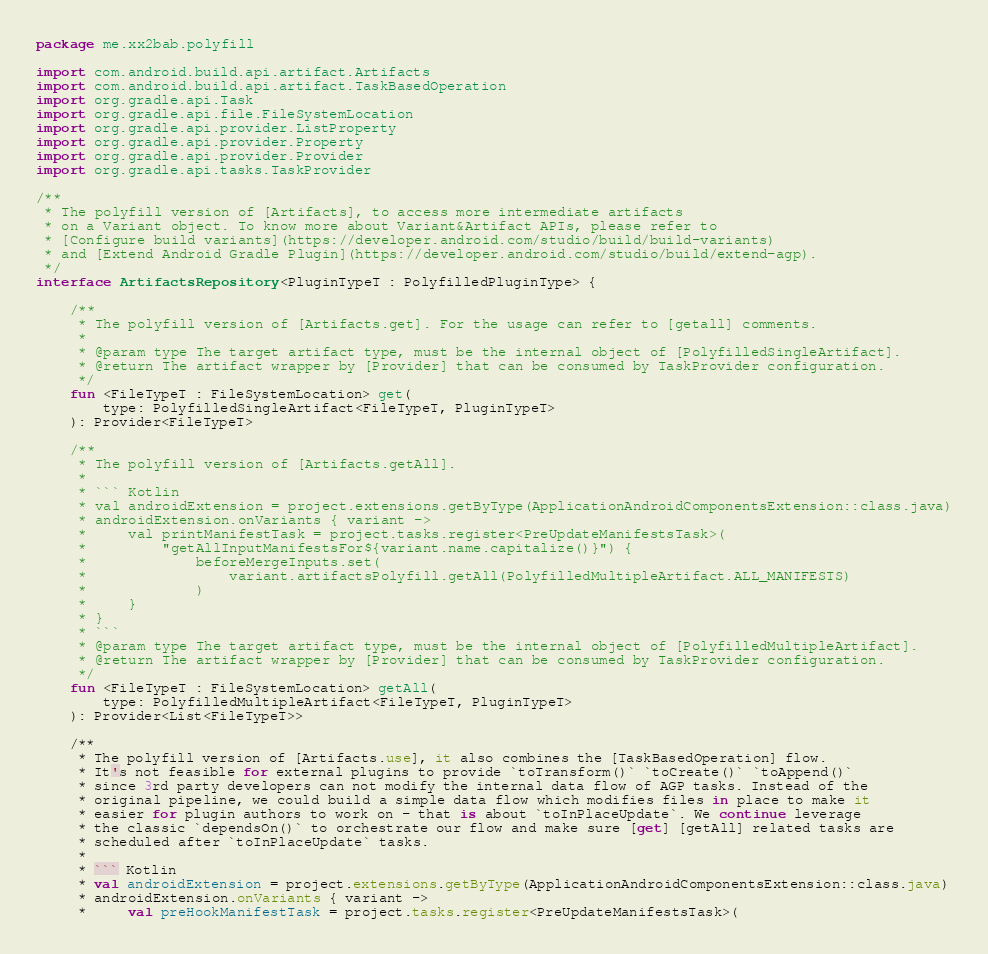Convert code to text. <code><loc_0><loc_0><loc_500><loc_500><_Kotlin_>package me.xx2bab.polyfill

import com.android.build.api.artifact.Artifacts
import com.android.build.api.artifact.TaskBasedOperation
import org.gradle.api.Task
import org.gradle.api.file.FileSystemLocation
import org.gradle.api.provider.ListProperty
import org.gradle.api.provider.Property
import org.gradle.api.provider.Provider
import org.gradle.api.tasks.TaskProvider

/**
 * The polyfill version of [Artifacts], to access more intermediate artifacts
 * on a Variant object. To know more about Variant&Artifact APIs, please refer to
 * [Configure build variants](https://developer.android.com/studio/build/build-variants)
 * and [Extend Android Gradle Plugin](https://developer.android.com/studio/build/extend-agp).
 */
interface ArtifactsRepository<PluginTypeT : PolyfilledPluginType> {

    /**
     * The polyfill version of [Artifacts.get]. For the usage can refer to [getall] comments.
     *
     * @param type The target artifact type, must be the internal object of [PolyfilledSingleArtifact].
     * @return The artifact wrapper by [Provider] that can be consumed by TaskProvider configuration.
     */
    fun <FileTypeT : FileSystemLocation> get(
        type: PolyfilledSingleArtifact<FileTypeT, PluginTypeT>
    ): Provider<FileTypeT>

    /**
     * The polyfill version of [Artifacts.getAll].
     *
     * ``` Kotlin
     * val androidExtension = project.extensions.getByType(ApplicationAndroidComponentsExtension::class.java)
     * androidExtension.onVariants { variant ->
     *     val printManifestTask = project.tasks.register<PreUpdateManifestsTask>(
     *         "getAllInputManifestsFor${variant.name.capitalize()}") {
     *             beforeMergeInputs.set(
     *                 variant.artifactsPolyfill.getAll(PolyfilledMultipleArtifact.ALL_MANIFESTS)
     *             )
     *     }
     * }
     * ```
     * @param type The target artifact type, must be the internal object of [PolyfilledMultipleArtifact].
     * @return The artifact wrapper by [Provider] that can be consumed by TaskProvider configuration.
     */
    fun <FileTypeT : FileSystemLocation> getAll(
        type: PolyfilledMultipleArtifact<FileTypeT, PluginTypeT>
    ): Provider<List<FileTypeT>>

    /**
     * The polyfill version of [Artifacts.use], it also combines the [TaskBasedOperation] flow.
     * It's not feasible for external plugins to provide `toTransform()` `toCreate()` `toAppend()`
     * since 3rd party developers can not modify the internal data flow of AGP tasks. Instead of the
     * original pipeline, we could build a simple data flow which modifies files in place to make it
     * easier for plugin authors to work on - that is about `toInPlaceUpdate`. We continue leverage
     * the classic `dependsOn()` to orchestrate our flow and make sure [get] [getAll] related tasks are
     * scheduled after `toInPlaceUpdate` tasks.
     *
     * ``` Kotlin
     * val androidExtension = project.extensions.getByType(ApplicationAndroidComponentsExtension::class.java)
     * androidExtension.onVariants { variant ->
     *     val preHookManifestTask = project.tasks.register<PreUpdateManifestsTask>(</code> 